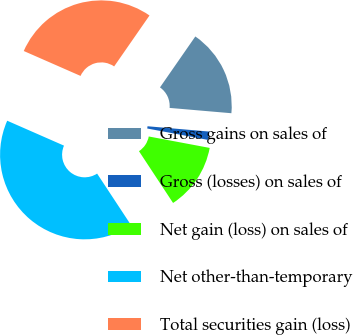Convert chart. <chart><loc_0><loc_0><loc_500><loc_500><pie_chart><fcel>Gross gains on sales of<fcel>Gross (losses) on sales of<fcel>Net gain (loss) on sales of<fcel>Net other-than-temporary<fcel>Total securities gain (loss)<nl><fcel>16.71%<fcel>1.59%<fcel>12.78%<fcel>40.85%<fcel>28.08%<nl></chart> 